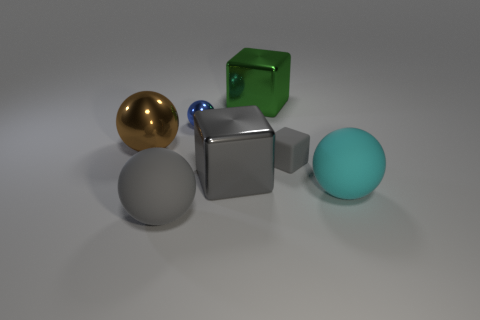What size is the other shiny cube that is the same color as the tiny block?
Make the answer very short. Large. What material is the sphere that is the same color as the tiny rubber thing?
Your response must be concise. Rubber. Are there any shiny things behind the large brown metal object?
Ensure brevity in your answer.  Yes. Do the large object on the right side of the green metallic object and the gray sphere have the same material?
Make the answer very short. Yes. Are there any large spheres of the same color as the rubber block?
Your answer should be very brief. Yes. What is the shape of the brown object?
Keep it short and to the point. Sphere. There is a large ball that is behind the big matte thing that is behind the gray matte ball; what is its color?
Ensure brevity in your answer.  Brown. How big is the metallic thing that is to the left of the blue thing?
Your response must be concise. Large. Are there any big brown spheres that have the same material as the small gray cube?
Your response must be concise. No. How many cyan matte things are the same shape as the blue metal object?
Your answer should be compact. 1. 